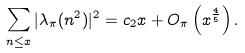Convert formula to latex. <formula><loc_0><loc_0><loc_500><loc_500>\sum _ { n \leq x } | \lambda _ { \pi } ( n ^ { 2 } ) | ^ { 2 } = c _ { 2 } x + O _ { \pi } \left ( x ^ { \frac { 4 } { 5 } } \right ) .</formula> 